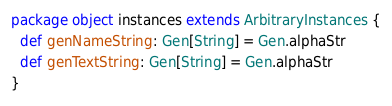<code> <loc_0><loc_0><loc_500><loc_500><_Scala_>package object instances extends ArbitraryInstances {
  def genNameString: Gen[String] = Gen.alphaStr
  def genTextString: Gen[String] = Gen.alphaStr
}</code> 